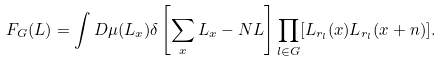<formula> <loc_0><loc_0><loc_500><loc_500>F _ { G } ( L ) = \int D \mu ( L _ { x } ) \delta \left [ \sum _ { x } L _ { x } - N L \right ] \prod _ { l \in G } [ L _ { r _ { l } } ( x ) L _ { r _ { l } } ( x + n ) ] .</formula> 